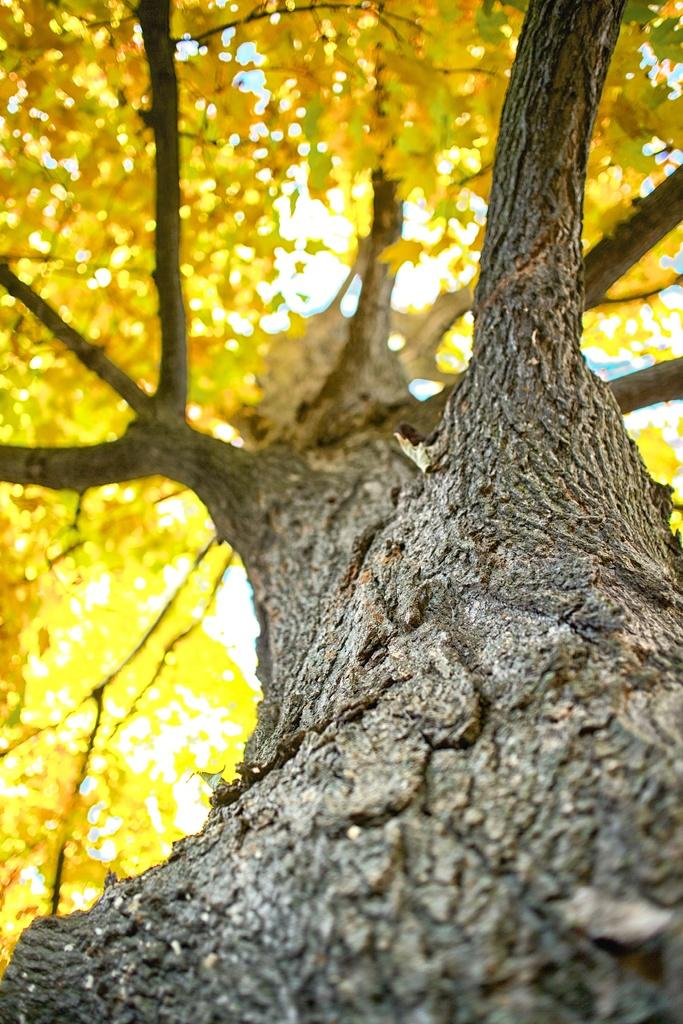What is the main subject of the image? There is a tree in the image. Can you describe the tree's features? The tree has branches, and the leaves on the branches are yellow in color. What type of shock can be seen on the yak in the image? There is no yak present in the image, and therefore no shock can be observed. 